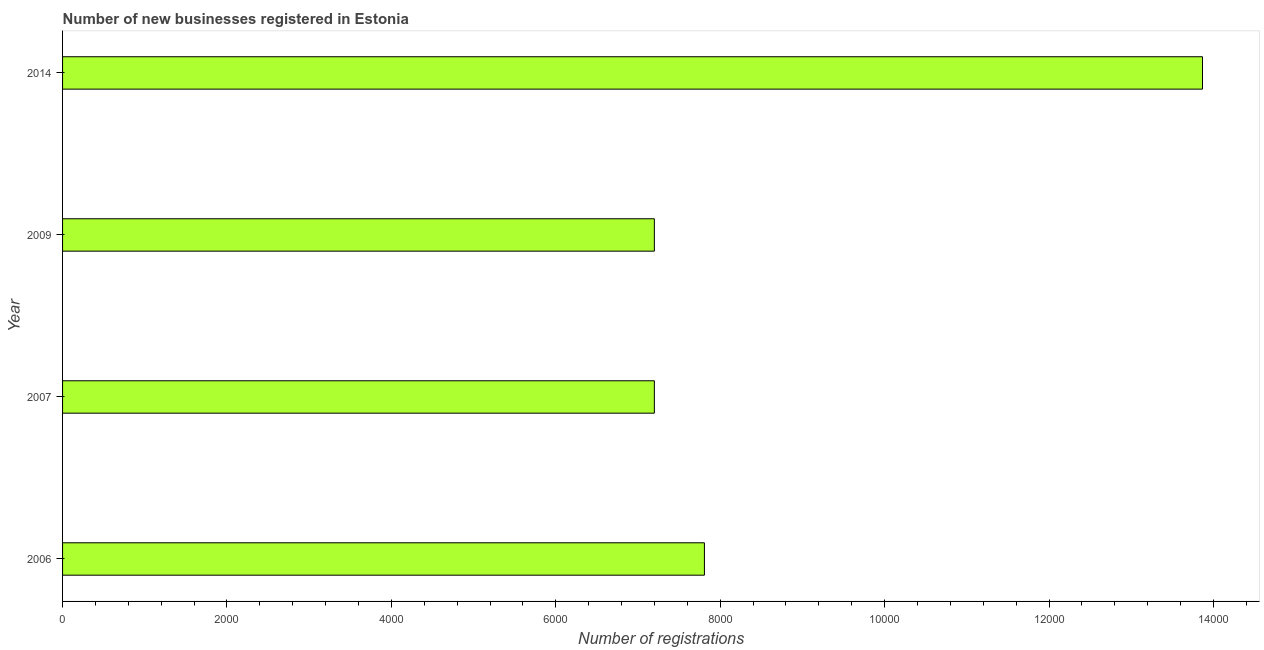What is the title of the graph?
Make the answer very short. Number of new businesses registered in Estonia. What is the label or title of the X-axis?
Offer a terse response. Number of registrations. What is the number of new business registrations in 2014?
Give a very brief answer. 1.39e+04. Across all years, what is the maximum number of new business registrations?
Offer a very short reply. 1.39e+04. Across all years, what is the minimum number of new business registrations?
Ensure brevity in your answer.  7199. What is the sum of the number of new business registrations?
Offer a very short reply. 3.61e+04. What is the difference between the number of new business registrations in 2009 and 2014?
Your answer should be very brief. -6668. What is the average number of new business registrations per year?
Your answer should be compact. 9018. What is the median number of new business registrations?
Keep it short and to the point. 7503.5. In how many years, is the number of new business registrations greater than 10000 ?
Make the answer very short. 1. Do a majority of the years between 2014 and 2009 (inclusive) have number of new business registrations greater than 4400 ?
Give a very brief answer. No. What is the ratio of the number of new business registrations in 2007 to that in 2014?
Offer a very short reply. 0.52. What is the difference between the highest and the second highest number of new business registrations?
Offer a terse response. 6059. What is the difference between the highest and the lowest number of new business registrations?
Your answer should be compact. 6668. In how many years, is the number of new business registrations greater than the average number of new business registrations taken over all years?
Your answer should be very brief. 1. How many bars are there?
Your response must be concise. 4. How many years are there in the graph?
Offer a terse response. 4. What is the difference between two consecutive major ticks on the X-axis?
Your response must be concise. 2000. Are the values on the major ticks of X-axis written in scientific E-notation?
Your answer should be very brief. No. What is the Number of registrations in 2006?
Provide a succinct answer. 7808. What is the Number of registrations in 2007?
Make the answer very short. 7199. What is the Number of registrations of 2009?
Ensure brevity in your answer.  7199. What is the Number of registrations in 2014?
Offer a terse response. 1.39e+04. What is the difference between the Number of registrations in 2006 and 2007?
Your answer should be very brief. 609. What is the difference between the Number of registrations in 2006 and 2009?
Make the answer very short. 609. What is the difference between the Number of registrations in 2006 and 2014?
Your answer should be compact. -6059. What is the difference between the Number of registrations in 2007 and 2009?
Your answer should be very brief. 0. What is the difference between the Number of registrations in 2007 and 2014?
Your response must be concise. -6668. What is the difference between the Number of registrations in 2009 and 2014?
Keep it short and to the point. -6668. What is the ratio of the Number of registrations in 2006 to that in 2007?
Offer a very short reply. 1.08. What is the ratio of the Number of registrations in 2006 to that in 2009?
Your answer should be compact. 1.08. What is the ratio of the Number of registrations in 2006 to that in 2014?
Make the answer very short. 0.56. What is the ratio of the Number of registrations in 2007 to that in 2014?
Keep it short and to the point. 0.52. What is the ratio of the Number of registrations in 2009 to that in 2014?
Make the answer very short. 0.52. 